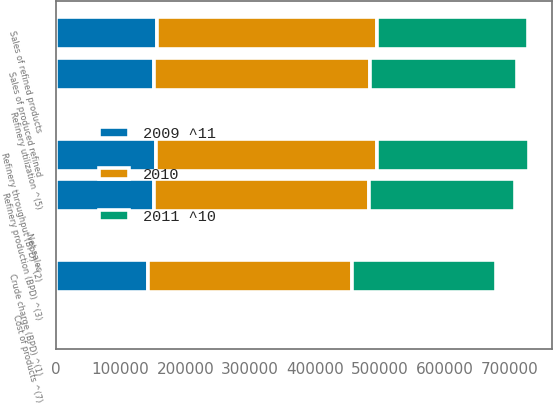<chart> <loc_0><loc_0><loc_500><loc_500><stacked_bar_chart><ecel><fcel>Crude charge (BPD) ^(1)<fcel>Refinery throughput (BPD) ^(2)<fcel>Refinery production (BPD) ^(3)<fcel>Sales of produced refined<fcel>Sales of refined products<fcel>Refinery utilization ^(5)<fcel>Net sales<fcel>Cost of products ^(7)<nl><fcel>2010<fcel>315000<fcel>340200<fcel>331890<fcel>332720<fcel>340630<fcel>89.9<fcel>118.82<fcel>98.18<nl><fcel>2011 ^10<fcel>221440<fcel>234910<fcel>225980<fcel>228140<fcel>232100<fcel>86.5<fcel>91.06<fcel>82.27<nl><fcel>2009 ^11<fcel>142430<fcel>154940<fcel>151420<fcel>151580<fcel>155820<fcel>78.9<fcel>74.06<fcel>66.85<nl></chart> 